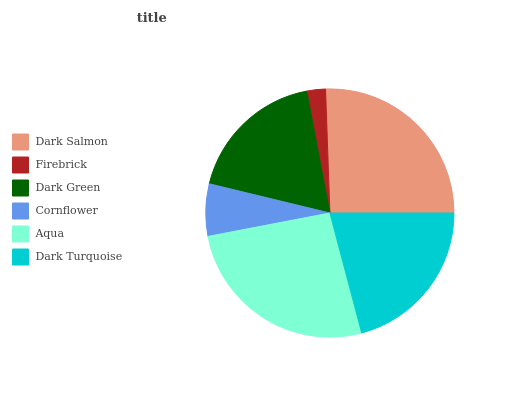Is Firebrick the minimum?
Answer yes or no. Yes. Is Aqua the maximum?
Answer yes or no. Yes. Is Dark Green the minimum?
Answer yes or no. No. Is Dark Green the maximum?
Answer yes or no. No. Is Dark Green greater than Firebrick?
Answer yes or no. Yes. Is Firebrick less than Dark Green?
Answer yes or no. Yes. Is Firebrick greater than Dark Green?
Answer yes or no. No. Is Dark Green less than Firebrick?
Answer yes or no. No. Is Dark Turquoise the high median?
Answer yes or no. Yes. Is Dark Green the low median?
Answer yes or no. Yes. Is Dark Salmon the high median?
Answer yes or no. No. Is Firebrick the low median?
Answer yes or no. No. 